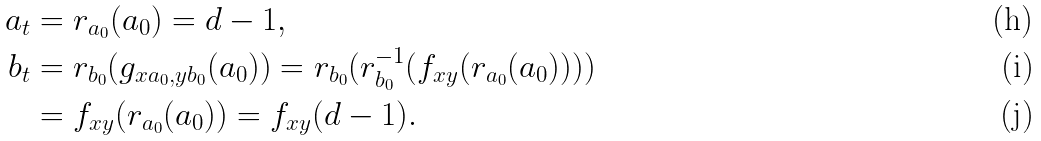<formula> <loc_0><loc_0><loc_500><loc_500>a _ { t } & = r _ { a _ { 0 } } ( a _ { 0 } ) = d - 1 , \\ b _ { t } & = r _ { b _ { 0 } } ( g _ { x a _ { 0 } , y b _ { 0 } } ( a _ { 0 } ) ) = r _ { b _ { 0 } } ( r _ { b _ { 0 } } ^ { - 1 } ( f _ { x y } ( r _ { a _ { 0 } } ( a _ { 0 } ) ) ) ) \\ & = f _ { x y } ( r _ { a _ { 0 } } ( a _ { 0 } ) ) = f _ { x y } ( d - 1 ) .</formula> 